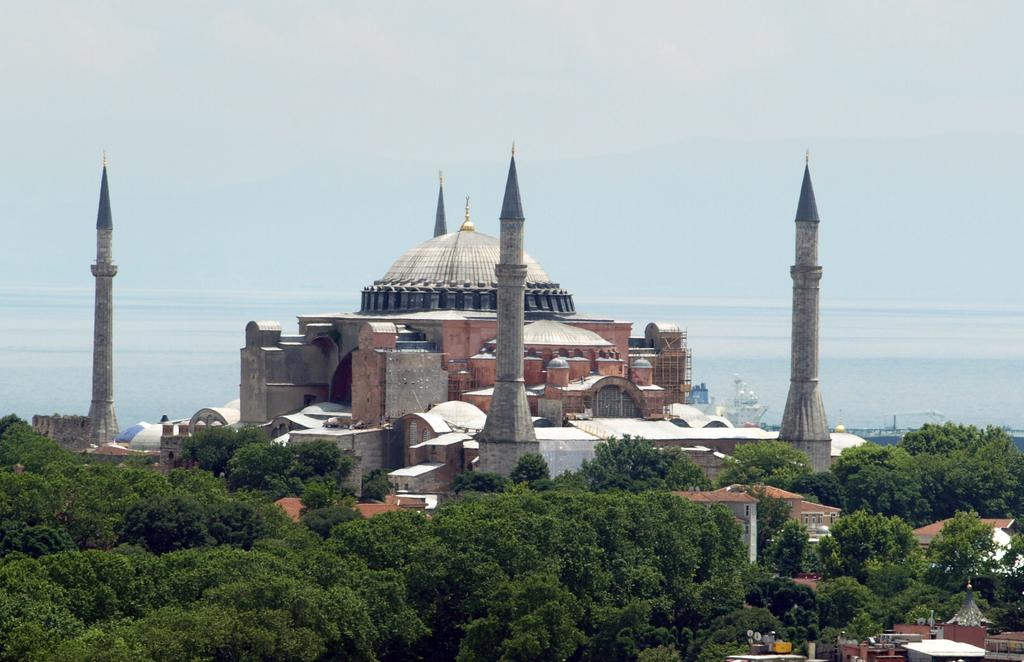What type of structures can be seen in the image? There are buildings and towers in the image. What other natural elements are present in the image? There are trees in the image. What type of appliance can be seen hanging from the trees in the image? There are no appliances present in the image, and no objects are hanging from the trees. 